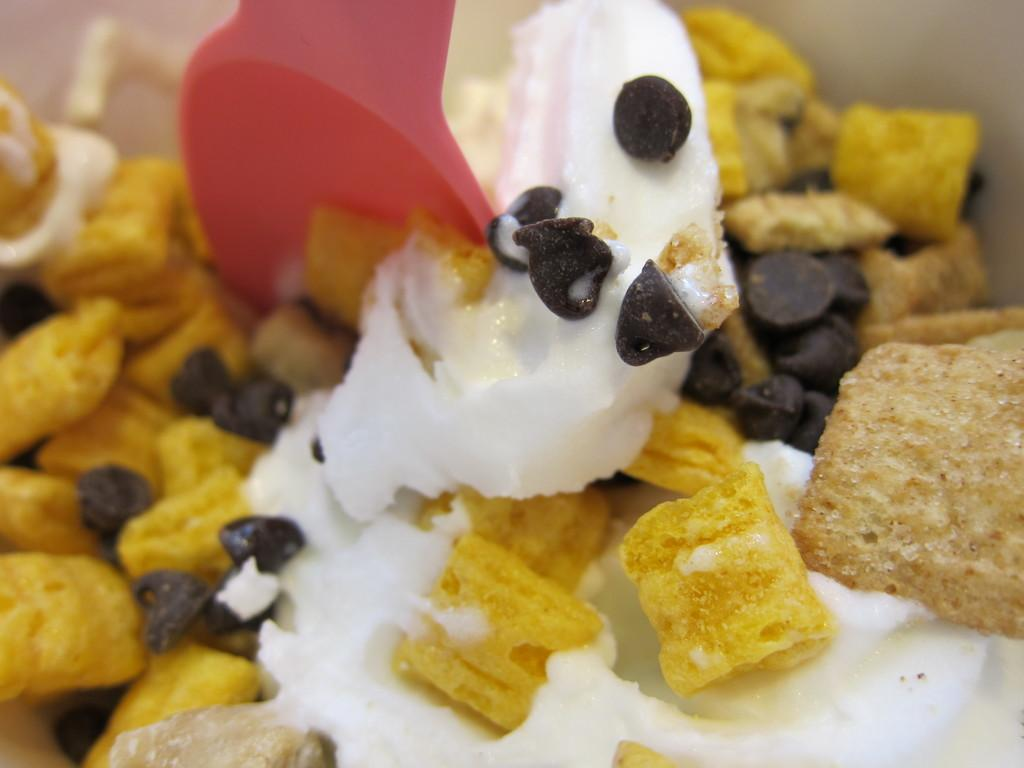What type of food item can be seen in the image? There is a food item in the image. What is a specific ingredient or component of the food item? There are chocolate chips in the image. What utensil is associated with the food item in the image? There is a spoon associated with the food item in the image. What type of note is attached to the butter in the image? There is no butter present in the image, and therefore no note attached to it. What type of support is visible in the image? There is no specific support structure visible in the image; it primarily features a food item, chocolate chips, and a spoon. 